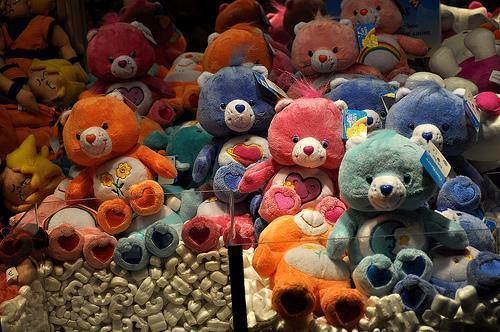How many dark blue bears are visible?
Give a very brief answer. 4. 